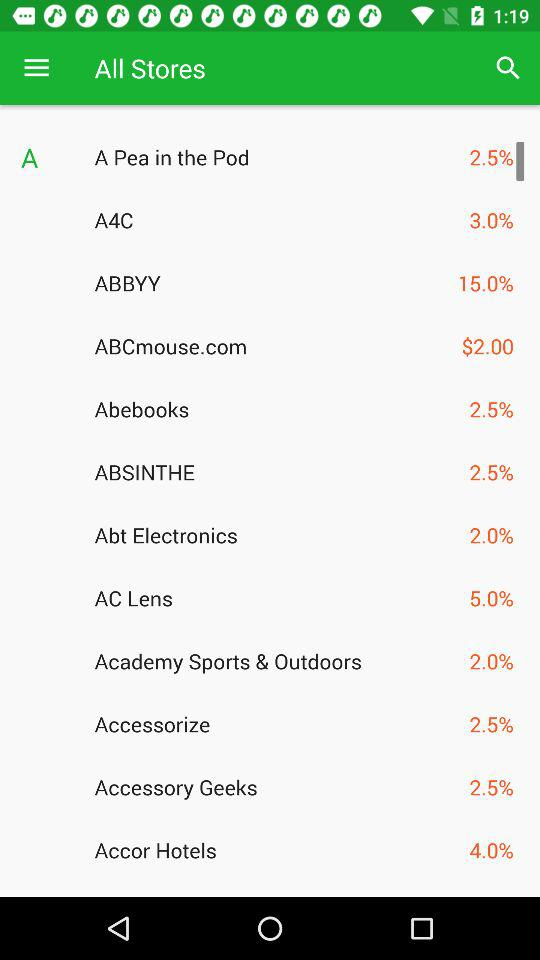What is the percentage shown for the AC Lens store? The percentage shown for the AC Lens store is 5. 